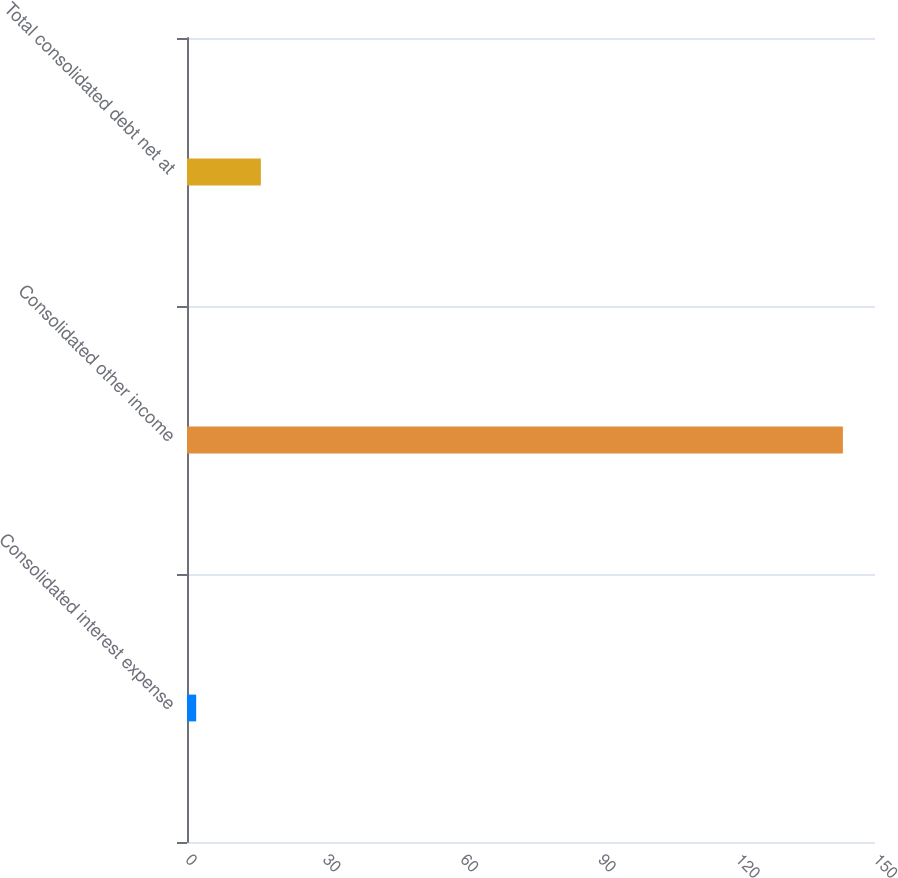Convert chart to OTSL. <chart><loc_0><loc_0><loc_500><loc_500><bar_chart><fcel>Consolidated interest expense<fcel>Consolidated other income<fcel>Total consolidated debt net at<nl><fcel>2<fcel>143<fcel>16.1<nl></chart> 